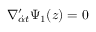Convert formula to latex. <formula><loc_0><loc_0><loc_500><loc_500>\nabla _ { { \dot { \alpha } } t } ^ { \prime } \Psi _ { 1 } ( z ) = 0</formula> 